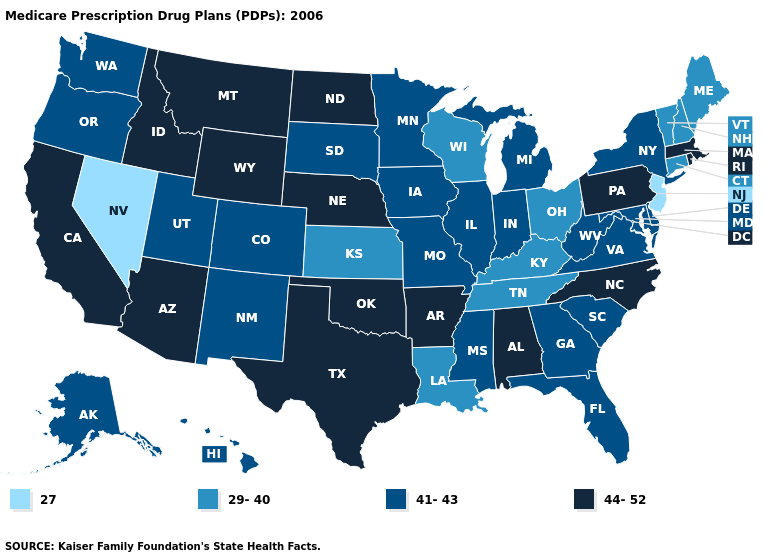What is the value of Maryland?
Give a very brief answer. 41-43. What is the lowest value in states that border Vermont?
Write a very short answer. 29-40. Which states have the lowest value in the South?
Quick response, please. Kentucky, Louisiana, Tennessee. What is the lowest value in the USA?
Keep it brief. 27. What is the value of Alabama?
Answer briefly. 44-52. What is the value of Tennessee?
Answer briefly. 29-40. Does the map have missing data?
Be succinct. No. Name the states that have a value in the range 44-52?
Concise answer only. Alabama, Arkansas, Arizona, California, Idaho, Massachusetts, Montana, North Carolina, North Dakota, Nebraska, Oklahoma, Pennsylvania, Rhode Island, Texas, Wyoming. What is the value of Wyoming?
Give a very brief answer. 44-52. Name the states that have a value in the range 44-52?
Be succinct. Alabama, Arkansas, Arizona, California, Idaho, Massachusetts, Montana, North Carolina, North Dakota, Nebraska, Oklahoma, Pennsylvania, Rhode Island, Texas, Wyoming. Name the states that have a value in the range 44-52?
Write a very short answer. Alabama, Arkansas, Arizona, California, Idaho, Massachusetts, Montana, North Carolina, North Dakota, Nebraska, Oklahoma, Pennsylvania, Rhode Island, Texas, Wyoming. What is the highest value in the Northeast ?
Write a very short answer. 44-52. Name the states that have a value in the range 29-40?
Answer briefly. Connecticut, Kansas, Kentucky, Louisiana, Maine, New Hampshire, Ohio, Tennessee, Vermont, Wisconsin. What is the highest value in the USA?
Give a very brief answer. 44-52. Name the states that have a value in the range 27?
Concise answer only. New Jersey, Nevada. 